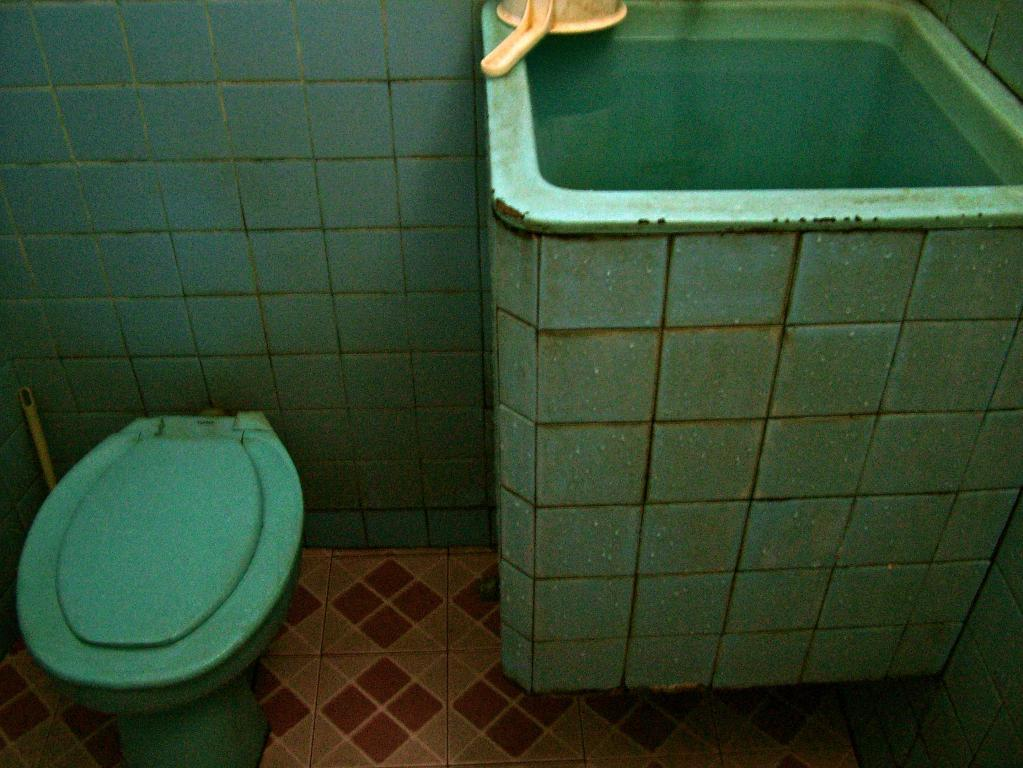What type of furniture is located on the left side of the image? There is a commode on the left side of the image. What other object can be seen in the image? There is a jug in the image. Where is the jug positioned in relation to the commode? The jug is at the top of the image. Is there any poison visible in the image? No, there is no poison present in the image. What type of fan can be seen in the image? There is no fan present in the image. 